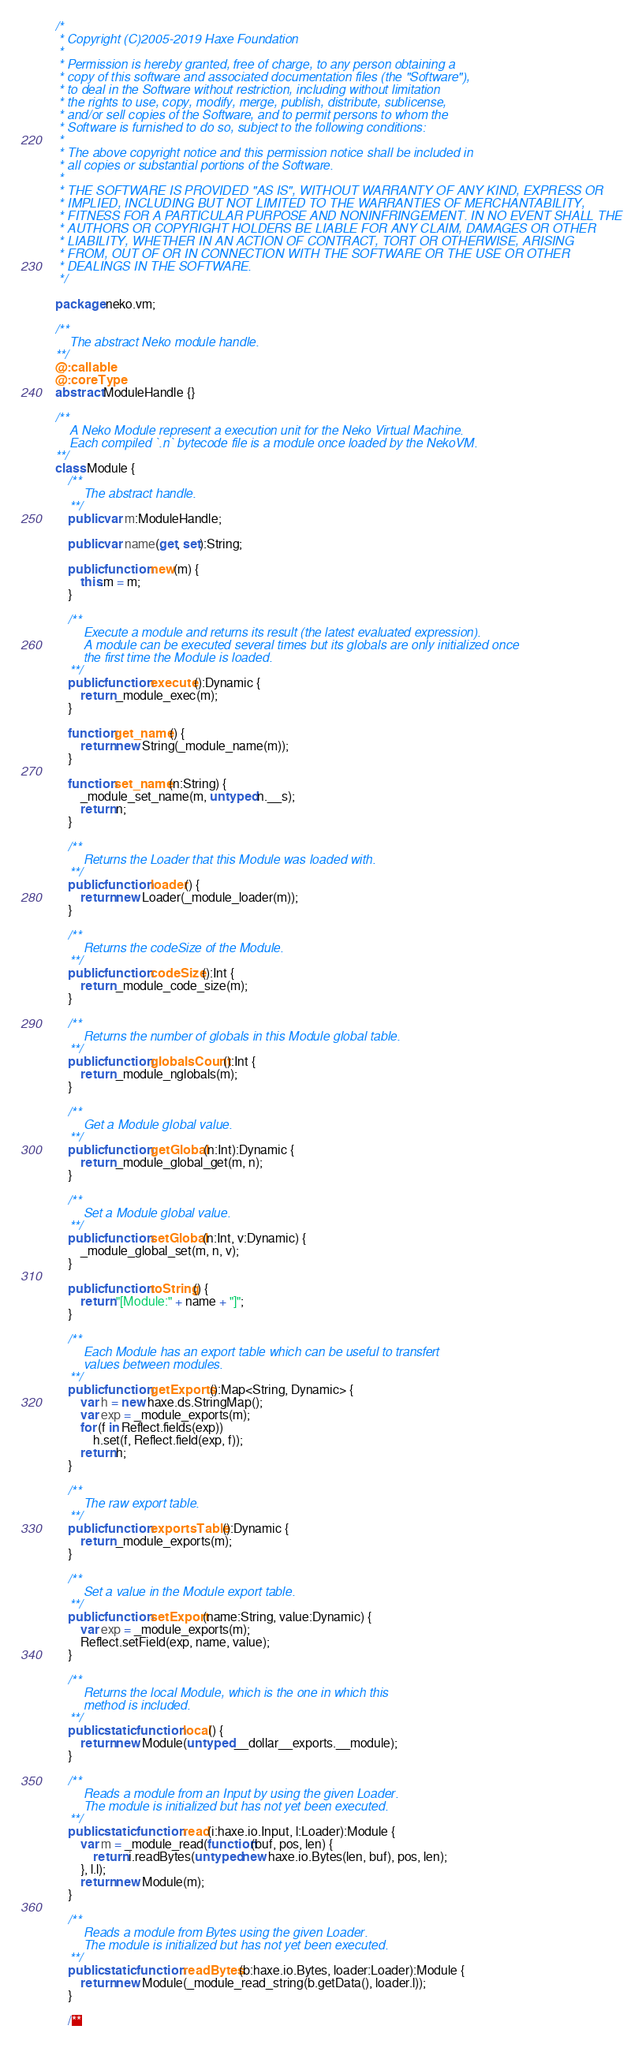Convert code to text. <code><loc_0><loc_0><loc_500><loc_500><_Haxe_>/*
 * Copyright (C)2005-2019 Haxe Foundation
 *
 * Permission is hereby granted, free of charge, to any person obtaining a
 * copy of this software and associated documentation files (the "Software"),
 * to deal in the Software without restriction, including without limitation
 * the rights to use, copy, modify, merge, publish, distribute, sublicense,
 * and/or sell copies of the Software, and to permit persons to whom the
 * Software is furnished to do so, subject to the following conditions:
 *
 * The above copyright notice and this permission notice shall be included in
 * all copies or substantial portions of the Software.
 *
 * THE SOFTWARE IS PROVIDED "AS IS", WITHOUT WARRANTY OF ANY KIND, EXPRESS OR
 * IMPLIED, INCLUDING BUT NOT LIMITED TO THE WARRANTIES OF MERCHANTABILITY,
 * FITNESS FOR A PARTICULAR PURPOSE AND NONINFRINGEMENT. IN NO EVENT SHALL THE
 * AUTHORS OR COPYRIGHT HOLDERS BE LIABLE FOR ANY CLAIM, DAMAGES OR OTHER
 * LIABILITY, WHETHER IN AN ACTION OF CONTRACT, TORT OR OTHERWISE, ARISING
 * FROM, OUT OF OR IN CONNECTION WITH THE SOFTWARE OR THE USE OR OTHER
 * DEALINGS IN THE SOFTWARE.
 */

package neko.vm;

/**
	The abstract Neko module handle.
**/
@:callable
@:coreType
abstract ModuleHandle {}

/**
	A Neko Module represent a execution unit for the Neko Virtual Machine.
	Each compiled `.n` bytecode file is a module once loaded by the NekoVM.
**/
class Module {
	/**
		The abstract handle.
	**/
	public var m:ModuleHandle;

	public var name(get, set):String;

	public function new(m) {
		this.m = m;
	}

	/**
		Execute a module and returns its result (the latest evaluated expression).
		A module can be executed several times but its globals are only initialized once
		the first time the Module is loaded.
	**/
	public function execute():Dynamic {
		return _module_exec(m);
	}

	function get_name() {
		return new String(_module_name(m));
	}

	function set_name(n:String) {
		_module_set_name(m, untyped n.__s);
		return n;
	}

	/**
		Returns the Loader that this Module was loaded with.
	**/
	public function loader() {
		return new Loader(_module_loader(m));
	}

	/**
		Returns the codeSize of the Module.
	**/
	public function codeSize():Int {
		return _module_code_size(m);
	}

	/**
		Returns the number of globals in this Module global table.
	**/
	public function globalsCount():Int {
		return _module_nglobals(m);
	}

	/**
		Get a Module global value.
	**/
	public function getGlobal(n:Int):Dynamic {
		return _module_global_get(m, n);
	}

	/**
		Set a Module global value.
	**/
	public function setGlobal(n:Int, v:Dynamic) {
		_module_global_set(m, n, v);
	}

	public function toString() {
		return "[Module:" + name + "]";
	}

	/**
		Each Module has an export table which can be useful to transfert
		values between modules.
	**/
	public function getExports():Map<String, Dynamic> {
		var h = new haxe.ds.StringMap();
		var exp = _module_exports(m);
		for (f in Reflect.fields(exp))
			h.set(f, Reflect.field(exp, f));
		return h;
	}

	/**
		The raw export table.
	**/
	public function exportsTable():Dynamic {
		return _module_exports(m);
	}

	/**
		Set a value in the Module export table.
	**/
	public function setExport(name:String, value:Dynamic) {
		var exp = _module_exports(m);
		Reflect.setField(exp, name, value);
	}

	/**
		Returns the local Module, which is the one in which this
		method is included.
	**/
	public static function local() {
		return new Module(untyped __dollar__exports.__module);
	}

	/**
		Reads a module from an Input by using the given Loader.
		The module is initialized but has not yet been executed.
	**/
	public static function read(i:haxe.io.Input, l:Loader):Module {
		var m = _module_read(function(buf, pos, len) {
			return i.readBytes(untyped new haxe.io.Bytes(len, buf), pos, len);
		}, l.l);
		return new Module(m);
	}

	/**
		Reads a module from Bytes using the given Loader.
		The module is initialized but has not yet been executed.
	**/
	public static function readBytes(b:haxe.io.Bytes, loader:Loader):Module {
		return new Module(_module_read_string(b.getData(), loader.l));
	}

	/**</code> 